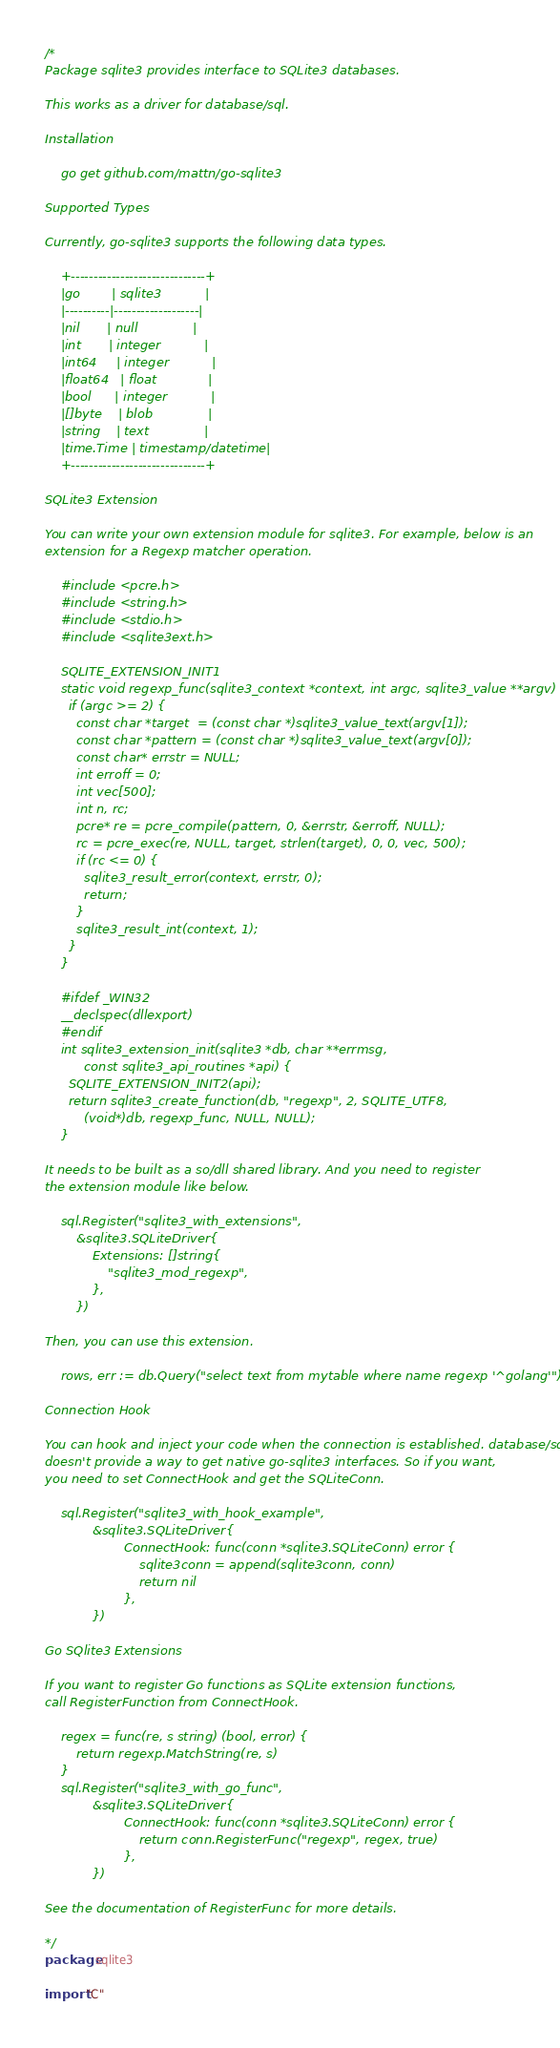<code> <loc_0><loc_0><loc_500><loc_500><_Go_>/*
Package sqlite3 provides interface to SQLite3 databases.

This works as a driver for database/sql.

Installation

    go get github.com/mattn/go-sqlite3

Supported Types

Currently, go-sqlite3 supports the following data types.

    +------------------------------+
    |go        | sqlite3           |
    |----------|-------------------|
    |nil       | null              |
    |int       | integer           |
    |int64     | integer           |
    |float64   | float             |
    |bool      | integer           |
    |[]byte    | blob              |
    |string    | text              |
    |time.Time | timestamp/datetime|
    +------------------------------+

SQLite3 Extension

You can write your own extension module for sqlite3. For example, below is an
extension for a Regexp matcher operation.

    #include <pcre.h>
    #include <string.h>
    #include <stdio.h>
    #include <sqlite3ext.h>

    SQLITE_EXTENSION_INIT1
    static void regexp_func(sqlite3_context *context, int argc, sqlite3_value **argv) {
      if (argc >= 2) {
        const char *target  = (const char *)sqlite3_value_text(argv[1]);
        const char *pattern = (const char *)sqlite3_value_text(argv[0]);
        const char* errstr = NULL;
        int erroff = 0;
        int vec[500];
        int n, rc;
        pcre* re = pcre_compile(pattern, 0, &errstr, &erroff, NULL);
        rc = pcre_exec(re, NULL, target, strlen(target), 0, 0, vec, 500);
        if (rc <= 0) {
          sqlite3_result_error(context, errstr, 0);
          return;
        }
        sqlite3_result_int(context, 1);
      }
    }

    #ifdef _WIN32
    __declspec(dllexport)
    #endif
    int sqlite3_extension_init(sqlite3 *db, char **errmsg,
          const sqlite3_api_routines *api) {
      SQLITE_EXTENSION_INIT2(api);
      return sqlite3_create_function(db, "regexp", 2, SQLITE_UTF8,
          (void*)db, regexp_func, NULL, NULL);
    }

It needs to be built as a so/dll shared library. And you need to register
the extension module like below.

	sql.Register("sqlite3_with_extensions",
		&sqlite3.SQLiteDriver{
			Extensions: []string{
				"sqlite3_mod_regexp",
			},
		})

Then, you can use this extension.

	rows, err := db.Query("select text from mytable where name regexp '^golang'")

Connection Hook

You can hook and inject your code when the connection is established. database/sql
doesn't provide a way to get native go-sqlite3 interfaces. So if you want,
you need to set ConnectHook and get the SQLiteConn.

	sql.Register("sqlite3_with_hook_example",
			&sqlite3.SQLiteDriver{
					ConnectHook: func(conn *sqlite3.SQLiteConn) error {
						sqlite3conn = append(sqlite3conn, conn)
						return nil
					},
			})

Go SQlite3 Extensions

If you want to register Go functions as SQLite extension functions,
call RegisterFunction from ConnectHook.

	regex = func(re, s string) (bool, error) {
		return regexp.MatchString(re, s)
	}
	sql.Register("sqlite3_with_go_func",
			&sqlite3.SQLiteDriver{
					ConnectHook: func(conn *sqlite3.SQLiteConn) error {
						return conn.RegisterFunc("regexp", regex, true)
					},
			})

See the documentation of RegisterFunc for more details.

*/
package sqlite3

import "C"
</code> 